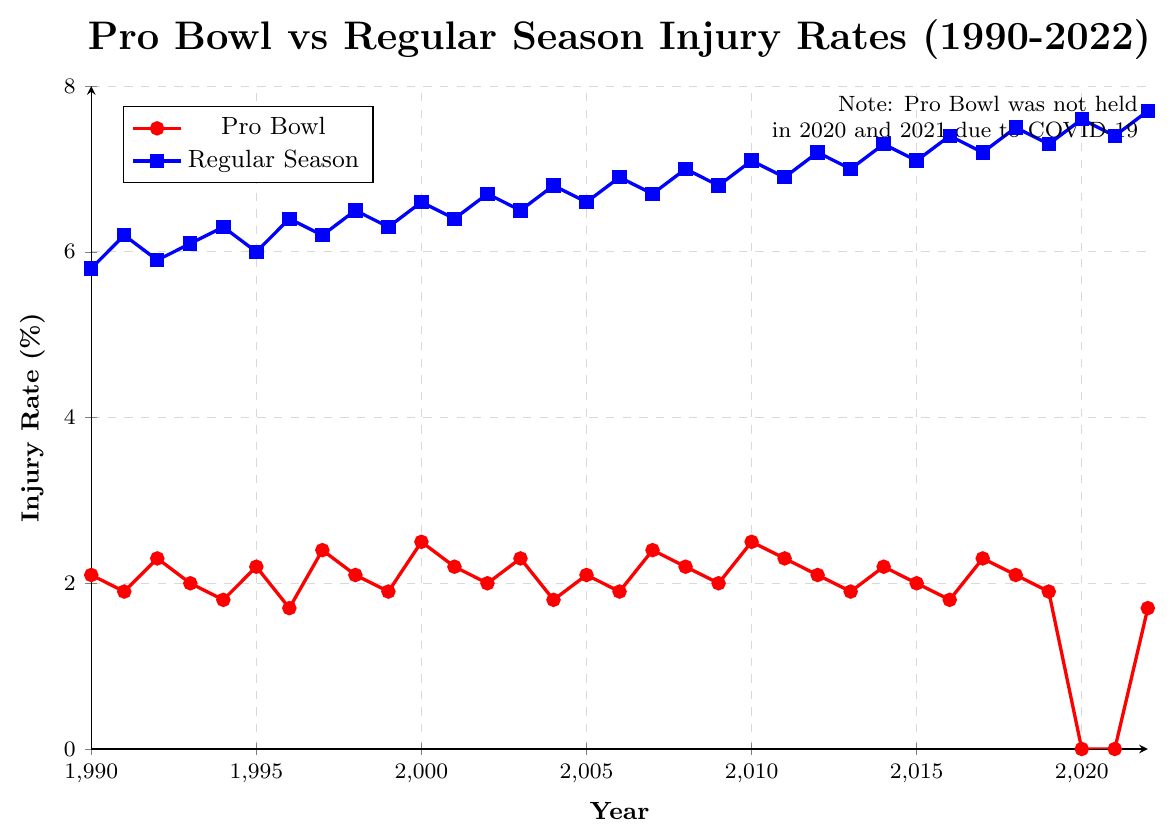What's the average injury rate for the Pro Bowl from 1990 to 2022? First, sum up all the Pro Bowl injury rates from 1990 to 2022. There are 33 data points (ignoring the two 0.0 values in 2020 and 2021): 2.1 + 1.9 + 2.3 + 2.0 + 1.8 + 2.2 + 1.7 + 2.4 + 2.1 + 1.9 + 2.5 + 2.2 + 2.0 + 2.3 + 1.8 + 2.1 + 1.9 + 2.4 + 2.2 + 2.0 + 2.5 + 2.3 + 2.1 + 1.9 + 2.2 + 2.0 + 1.8 + 2.3 + 2.1 + 1.9 + 1.7 = 62.2. Divide the sum by 33: 62.2 / 33 ≈ 1.88
Answer: 1.88 How does the injury rate in the Pro Bowl in 2000 compare to that in the Regular Season? The Pro Bowl injury rate in 2000 is 2.5, and the Regular Season injury rate is 6.6. Comparing these two values, the Regular Season injury rate is higher.
Answer: Regular Season is higher What's the percentage change in the Pro Bowl injury rate from 1990 to 1996? The Pro Bowl injury rate in 1990 is 2.1 and in 1996 is 1.7. The percentage change is calculated as (1.7 - 2.1) / 2.1 * 100 = -19.05%.
Answer: -19.05% In which year did the Pro Bowl have its highest injury rate, and what was the rate? To find the highest injury rate in the Pro Bowl line, look for the peak point. The highest rate is in 2010 at 2.5%.
Answer: 2010, 2.5% Compare the general trends in the injury rates for the Pro Bowl and Regular Season from 1990 to 2022. The Pro Bowl injury rate generally fluctuates around 2% with a notable drop to 0% in 2020 and 2021. The Regular Season injury rate shows a consistent increase from around 6% to 7.7% in 2022. Overall, the Regular Season injury rate has increased, while the Pro Bowl has remained relatively stable with small fluctuations.
Answer: Regular Season increasing, Pro Bowl stable In which year is the difference between the Pro Bowl and Regular Season injury rates the smallest? The differences are calculated for each year from 1990 to 2022. The smallest difference is seen in 1996, where Pro Bowl is 1.7 and Regular Season is 6.4, yielding a difference of 4.7.
Answer: 1996 Which two consecutive years had the most significant drop in Regular Season injury rates? Calculate the differences between consecutive years for Regular Season. The largest drop is from 2018 (7.5) to 2019 (7.3), a decrease of 0.2.
Answer: 2018-2019 Explain the visual contrast between the Pro Bowl and Regular Season injury rates shown in the chart. The Pro Bowl injury rates are consistently lower and depicted with red dots, showing minimal annual variation. In contrast, the Regular Season injury rates, represented by blue squares, are higher with a visible upward trend over the years. The gray dashed gridlines help make this difference clear by highlighting the overall increase in Regular Season injuries.
Answer: Pro Bowl lower and stable, Regular Season higher and increasing 